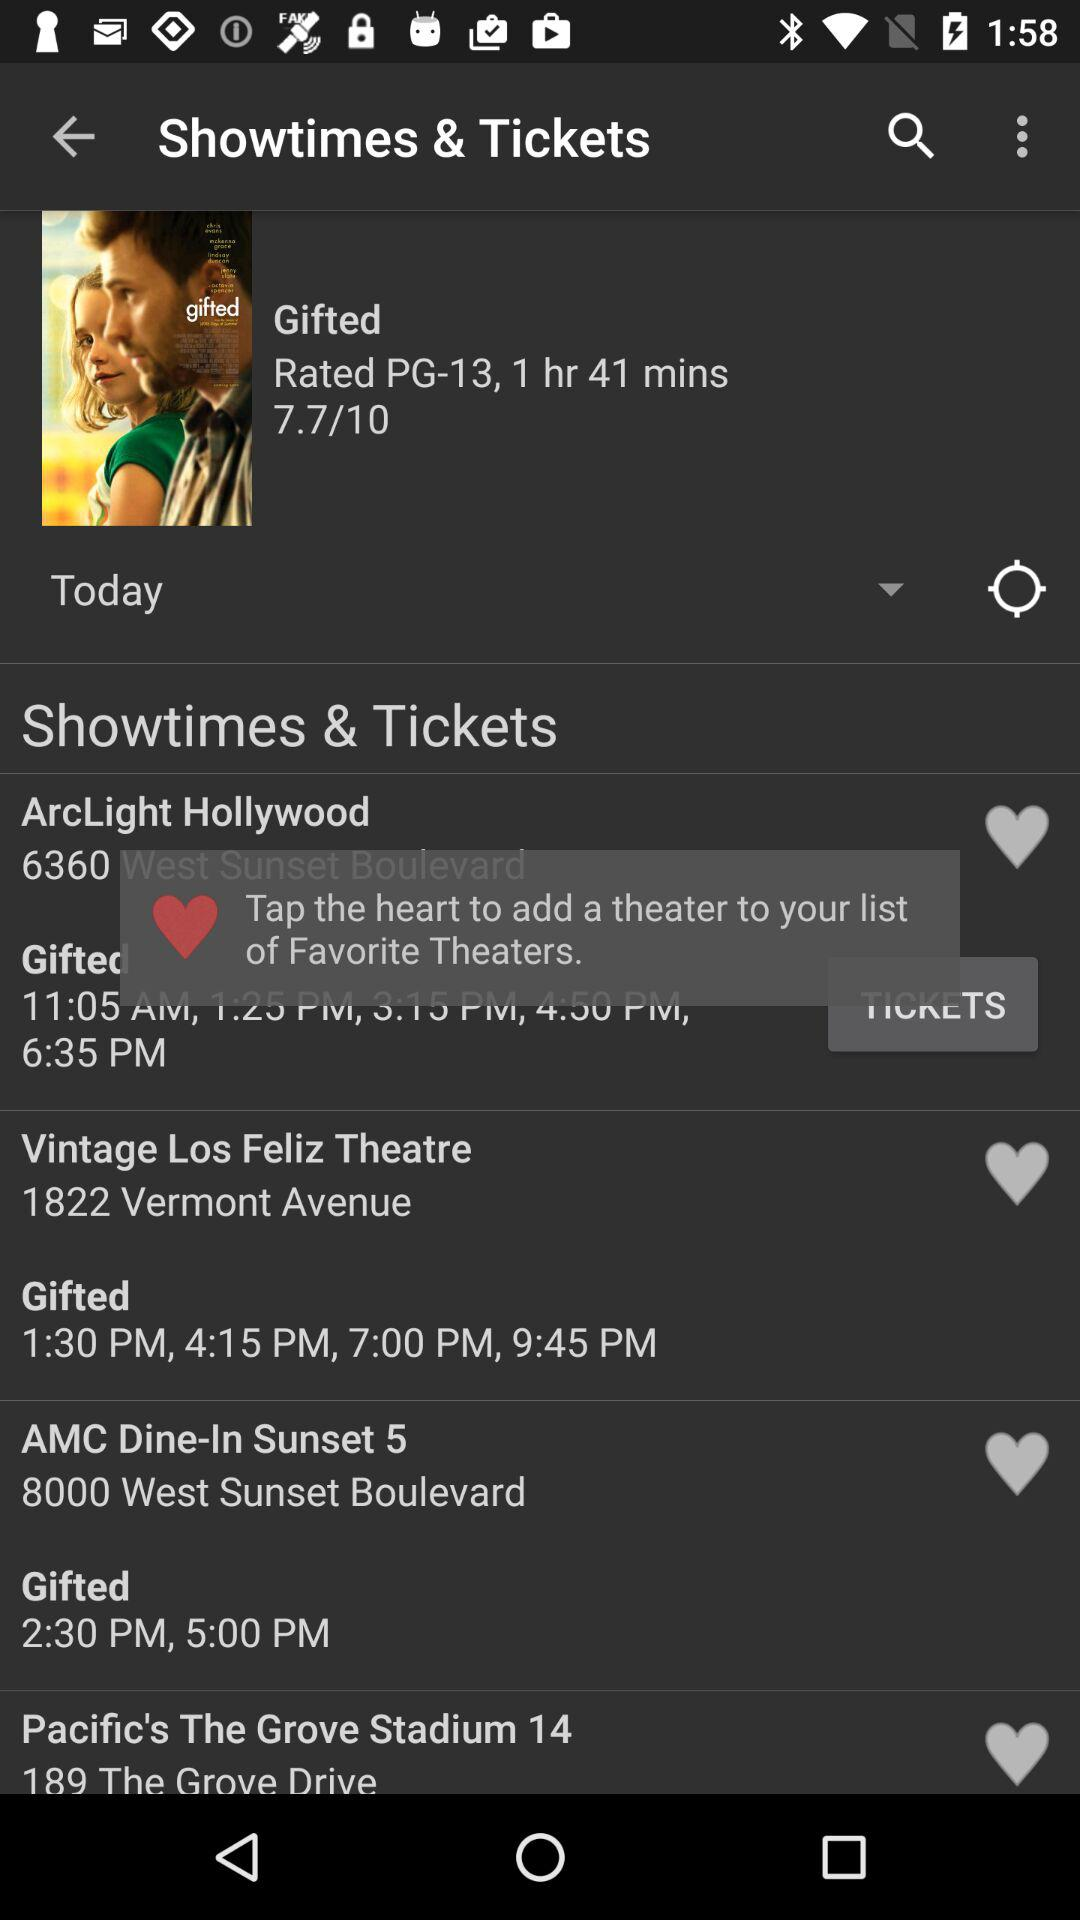What is the address of the "Vintage Los Feliz Theatre"? The address of the "Vintage Los Feliz Theatre" is 1822 Vermont Avenue. 